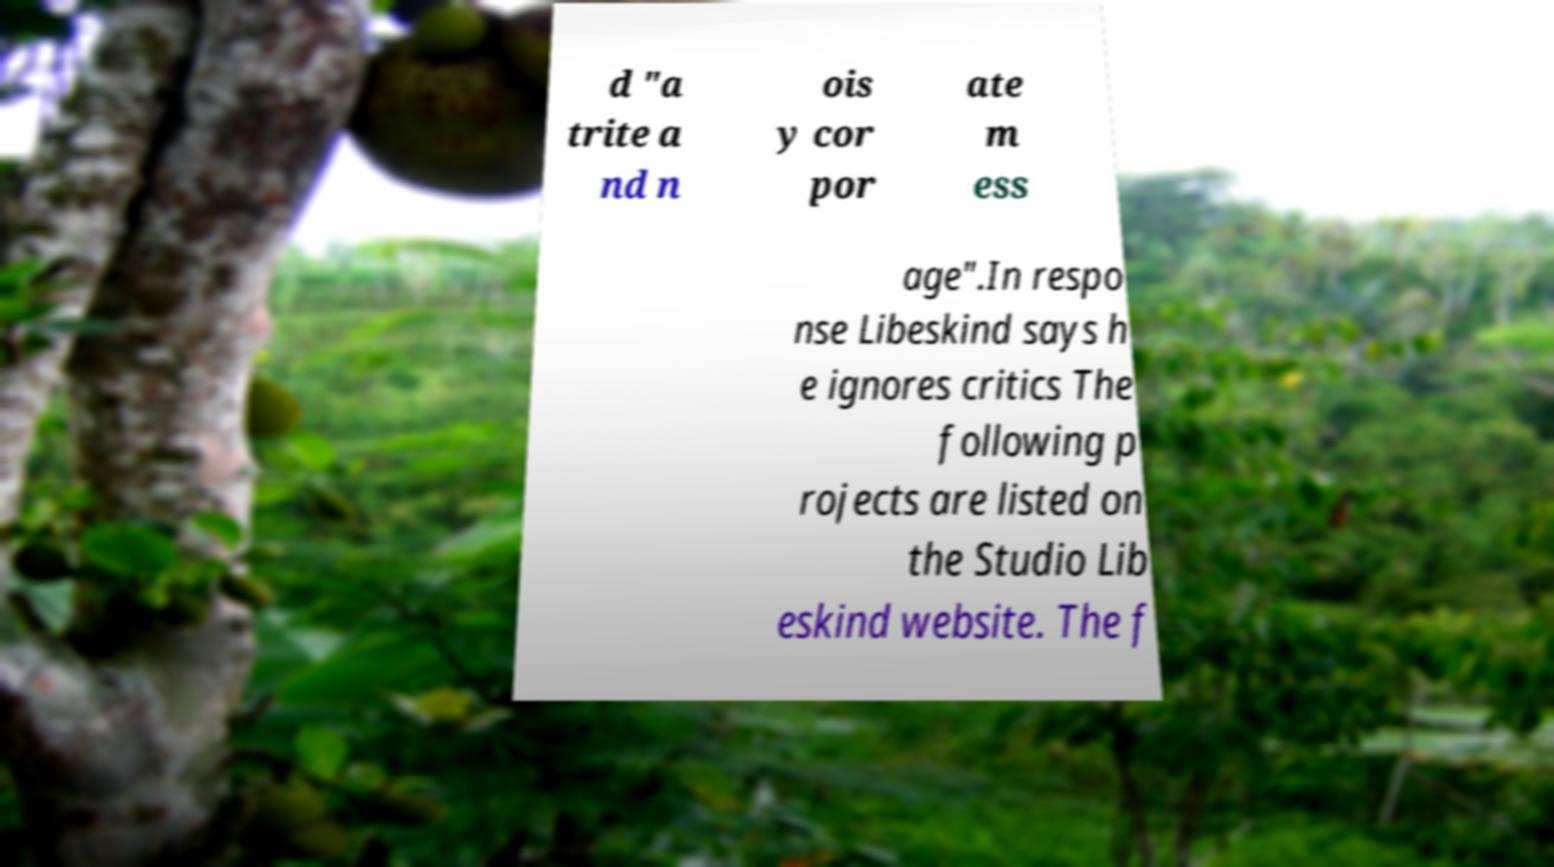Could you extract and type out the text from this image? d "a trite a nd n ois y cor por ate m ess age".In respo nse Libeskind says h e ignores critics The following p rojects are listed on the Studio Lib eskind website. The f 